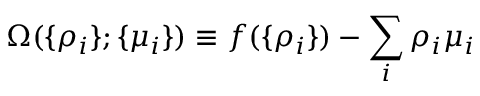Convert formula to latex. <formula><loc_0><loc_0><loc_500><loc_500>\Omega ( \{ \rho _ { i } \} ; \{ \mu _ { i } \} ) \equiv f ( \{ \rho _ { i } \} ) - \sum _ { i } \rho _ { i } \mu _ { i }</formula> 